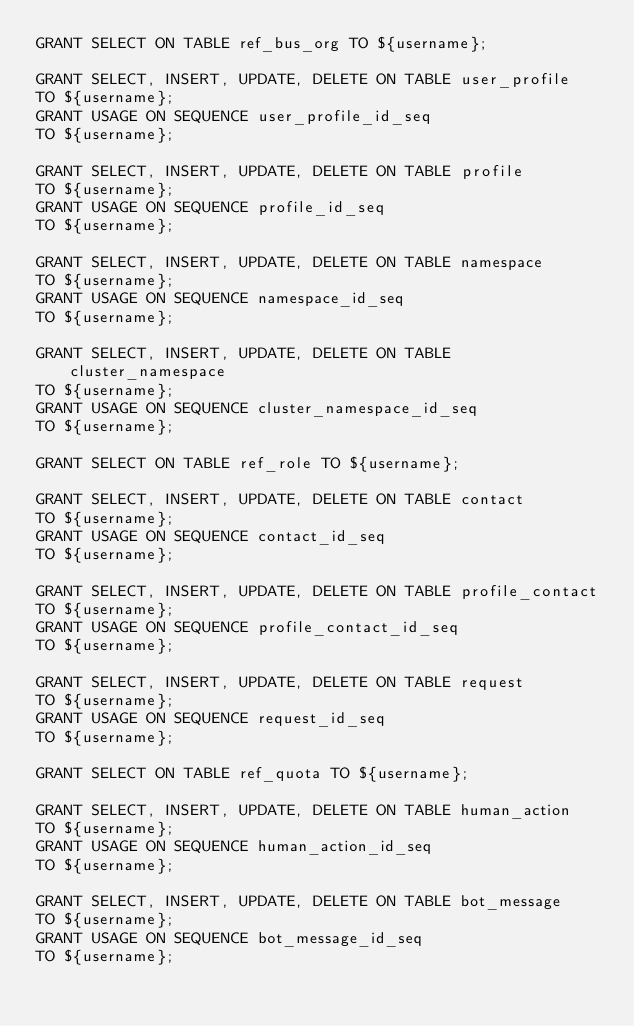Convert code to text. <code><loc_0><loc_0><loc_500><loc_500><_SQL_>GRANT SELECT ON TABLE ref_bus_org TO ${username};

GRANT SELECT, INSERT, UPDATE, DELETE ON TABLE user_profile
TO ${username};
GRANT USAGE ON SEQUENCE user_profile_id_seq
TO ${username};

GRANT SELECT, INSERT, UPDATE, DELETE ON TABLE profile
TO ${username};
GRANT USAGE ON SEQUENCE profile_id_seq
TO ${username};

GRANT SELECT, INSERT, UPDATE, DELETE ON TABLE namespace
TO ${username};
GRANT USAGE ON SEQUENCE namespace_id_seq
TO ${username};

GRANT SELECT, INSERT, UPDATE, DELETE ON TABLE cluster_namespace
TO ${username};
GRANT USAGE ON SEQUENCE cluster_namespace_id_seq
TO ${username};

GRANT SELECT ON TABLE ref_role TO ${username};

GRANT SELECT, INSERT, UPDATE, DELETE ON TABLE contact
TO ${username};
GRANT USAGE ON SEQUENCE contact_id_seq
TO ${username};

GRANT SELECT, INSERT, UPDATE, DELETE ON TABLE profile_contact
TO ${username};
GRANT USAGE ON SEQUENCE profile_contact_id_seq
TO ${username};

GRANT SELECT, INSERT, UPDATE, DELETE ON TABLE request
TO ${username};
GRANT USAGE ON SEQUENCE request_id_seq
TO ${username};

GRANT SELECT ON TABLE ref_quota TO ${username};

GRANT SELECT, INSERT, UPDATE, DELETE ON TABLE human_action
TO ${username};
GRANT USAGE ON SEQUENCE human_action_id_seq
TO ${username};

GRANT SELECT, INSERT, UPDATE, DELETE ON TABLE bot_message
TO ${username};
GRANT USAGE ON SEQUENCE bot_message_id_seq
TO ${username};
</code> 